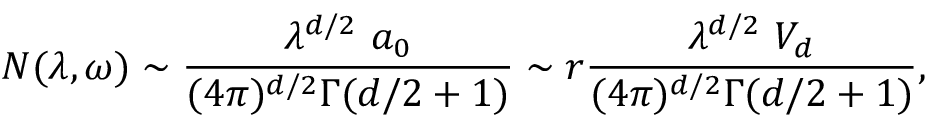Convert formula to latex. <formula><loc_0><loc_0><loc_500><loc_500>N ( \lambda , \omega ) \sim { \frac { \lambda ^ { d / 2 } a _ { 0 } } { ( 4 \pi ) ^ { d / 2 } \Gamma ( d / 2 + 1 ) } } \sim r { \frac { \lambda ^ { d / 2 } V _ { d } } { ( 4 \pi ) ^ { d / 2 } \Gamma ( d / 2 + 1 ) } } ,</formula> 